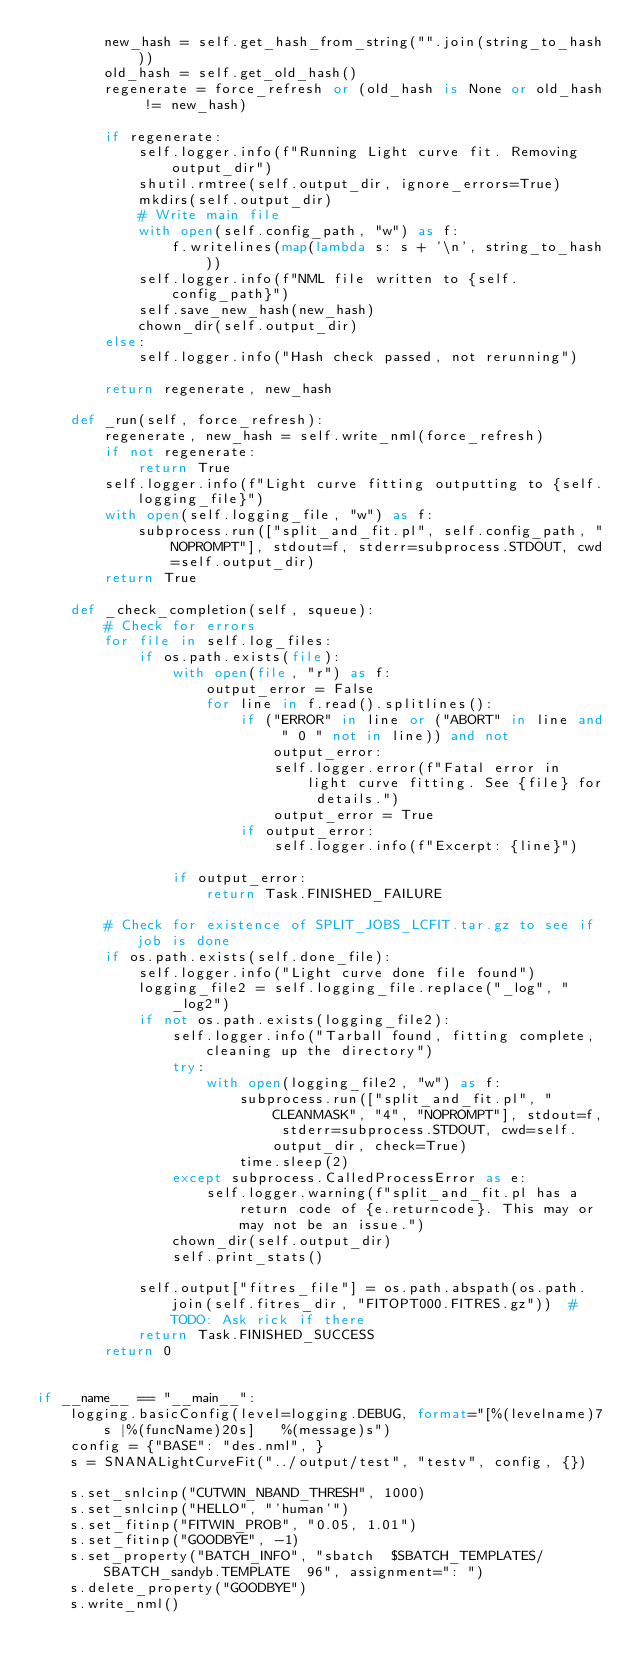<code> <loc_0><loc_0><loc_500><loc_500><_Python_>        new_hash = self.get_hash_from_string("".join(string_to_hash))
        old_hash = self.get_old_hash()
        regenerate = force_refresh or (old_hash is None or old_hash != new_hash)

        if regenerate:
            self.logger.info(f"Running Light curve fit. Removing output_dir")
            shutil.rmtree(self.output_dir, ignore_errors=True)
            mkdirs(self.output_dir)
            # Write main file
            with open(self.config_path, "w") as f:
                f.writelines(map(lambda s: s + '\n', string_to_hash))
            self.logger.info(f"NML file written to {self.config_path}")
            self.save_new_hash(new_hash)
            chown_dir(self.output_dir)
        else:
            self.logger.info("Hash check passed, not rerunning")

        return regenerate, new_hash

    def _run(self, force_refresh):
        regenerate, new_hash = self.write_nml(force_refresh)
        if not regenerate:
            return True
        self.logger.info(f"Light curve fitting outputting to {self.logging_file}")
        with open(self.logging_file, "w") as f:
            subprocess.run(["split_and_fit.pl", self.config_path, "NOPROMPT"], stdout=f, stderr=subprocess.STDOUT, cwd=self.output_dir)
        return True

    def _check_completion(self, squeue):
        # Check for errors
        for file in self.log_files:
            if os.path.exists(file):
                with open(file, "r") as f:
                    output_error = False
                    for line in f.read().splitlines():
                        if ("ERROR" in line or ("ABORT" in line and " 0 " not in line)) and not output_error:
                            self.logger.error(f"Fatal error in light curve fitting. See {file} for details.")
                            output_error = True
                        if output_error:
                            self.logger.info(f"Excerpt: {line}")

                if output_error:
                    return Task.FINISHED_FAILURE

        # Check for existence of SPLIT_JOBS_LCFIT.tar.gz to see if job is done
        if os.path.exists(self.done_file):
            self.logger.info("Light curve done file found")
            logging_file2 = self.logging_file.replace("_log", "_log2")
            if not os.path.exists(logging_file2):
                self.logger.info("Tarball found, fitting complete, cleaning up the directory")
                try:
                    with open(logging_file2, "w") as f:
                        subprocess.run(["split_and_fit.pl", "CLEANMASK", "4", "NOPROMPT"], stdout=f, stderr=subprocess.STDOUT, cwd=self.output_dir, check=True)
                        time.sleep(2)
                except subprocess.CalledProcessError as e:
                    self.logger.warning(f"split_and_fit.pl has a return code of {e.returncode}. This may or may not be an issue.")
                chown_dir(self.output_dir)
                self.print_stats()

            self.output["fitres_file"] = os.path.abspath(os.path.join(self.fitres_dir, "FITOPT000.FITRES.gz"))  # TODO: Ask rick if there
            return Task.FINISHED_SUCCESS
        return 0


if __name__ == "__main__":
    logging.basicConfig(level=logging.DEBUG, format="[%(levelname)7s |%(funcName)20s]   %(message)s")
    config = {"BASE": "des.nml", }
    s = SNANALightCurveFit("../output/test", "testv", config, {})

    s.set_snlcinp("CUTWIN_NBAND_THRESH", 1000)
    s.set_snlcinp("HELLO", "'human'")
    s.set_fitinp("FITWIN_PROB", "0.05, 1.01")
    s.set_fitinp("GOODBYE", -1)
    s.set_property("BATCH_INFO", "sbatch  $SBATCH_TEMPLATES/SBATCH_sandyb.TEMPLATE  96", assignment=": ")
    s.delete_property("GOODBYE")
    s.write_nml()
</code> 